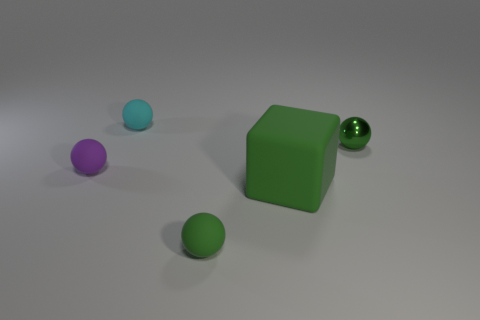Subtract all small green matte balls. How many balls are left? 3 Add 2 red matte cylinders. How many objects exist? 7 Subtract all brown balls. Subtract all blue cylinders. How many balls are left? 4 Subtract all balls. How many objects are left? 1 Subtract 0 red cubes. How many objects are left? 5 Subtract all tiny shiny spheres. Subtract all purple rubber objects. How many objects are left? 3 Add 4 big matte cubes. How many big matte cubes are left? 5 Add 2 small green matte balls. How many small green matte balls exist? 3 